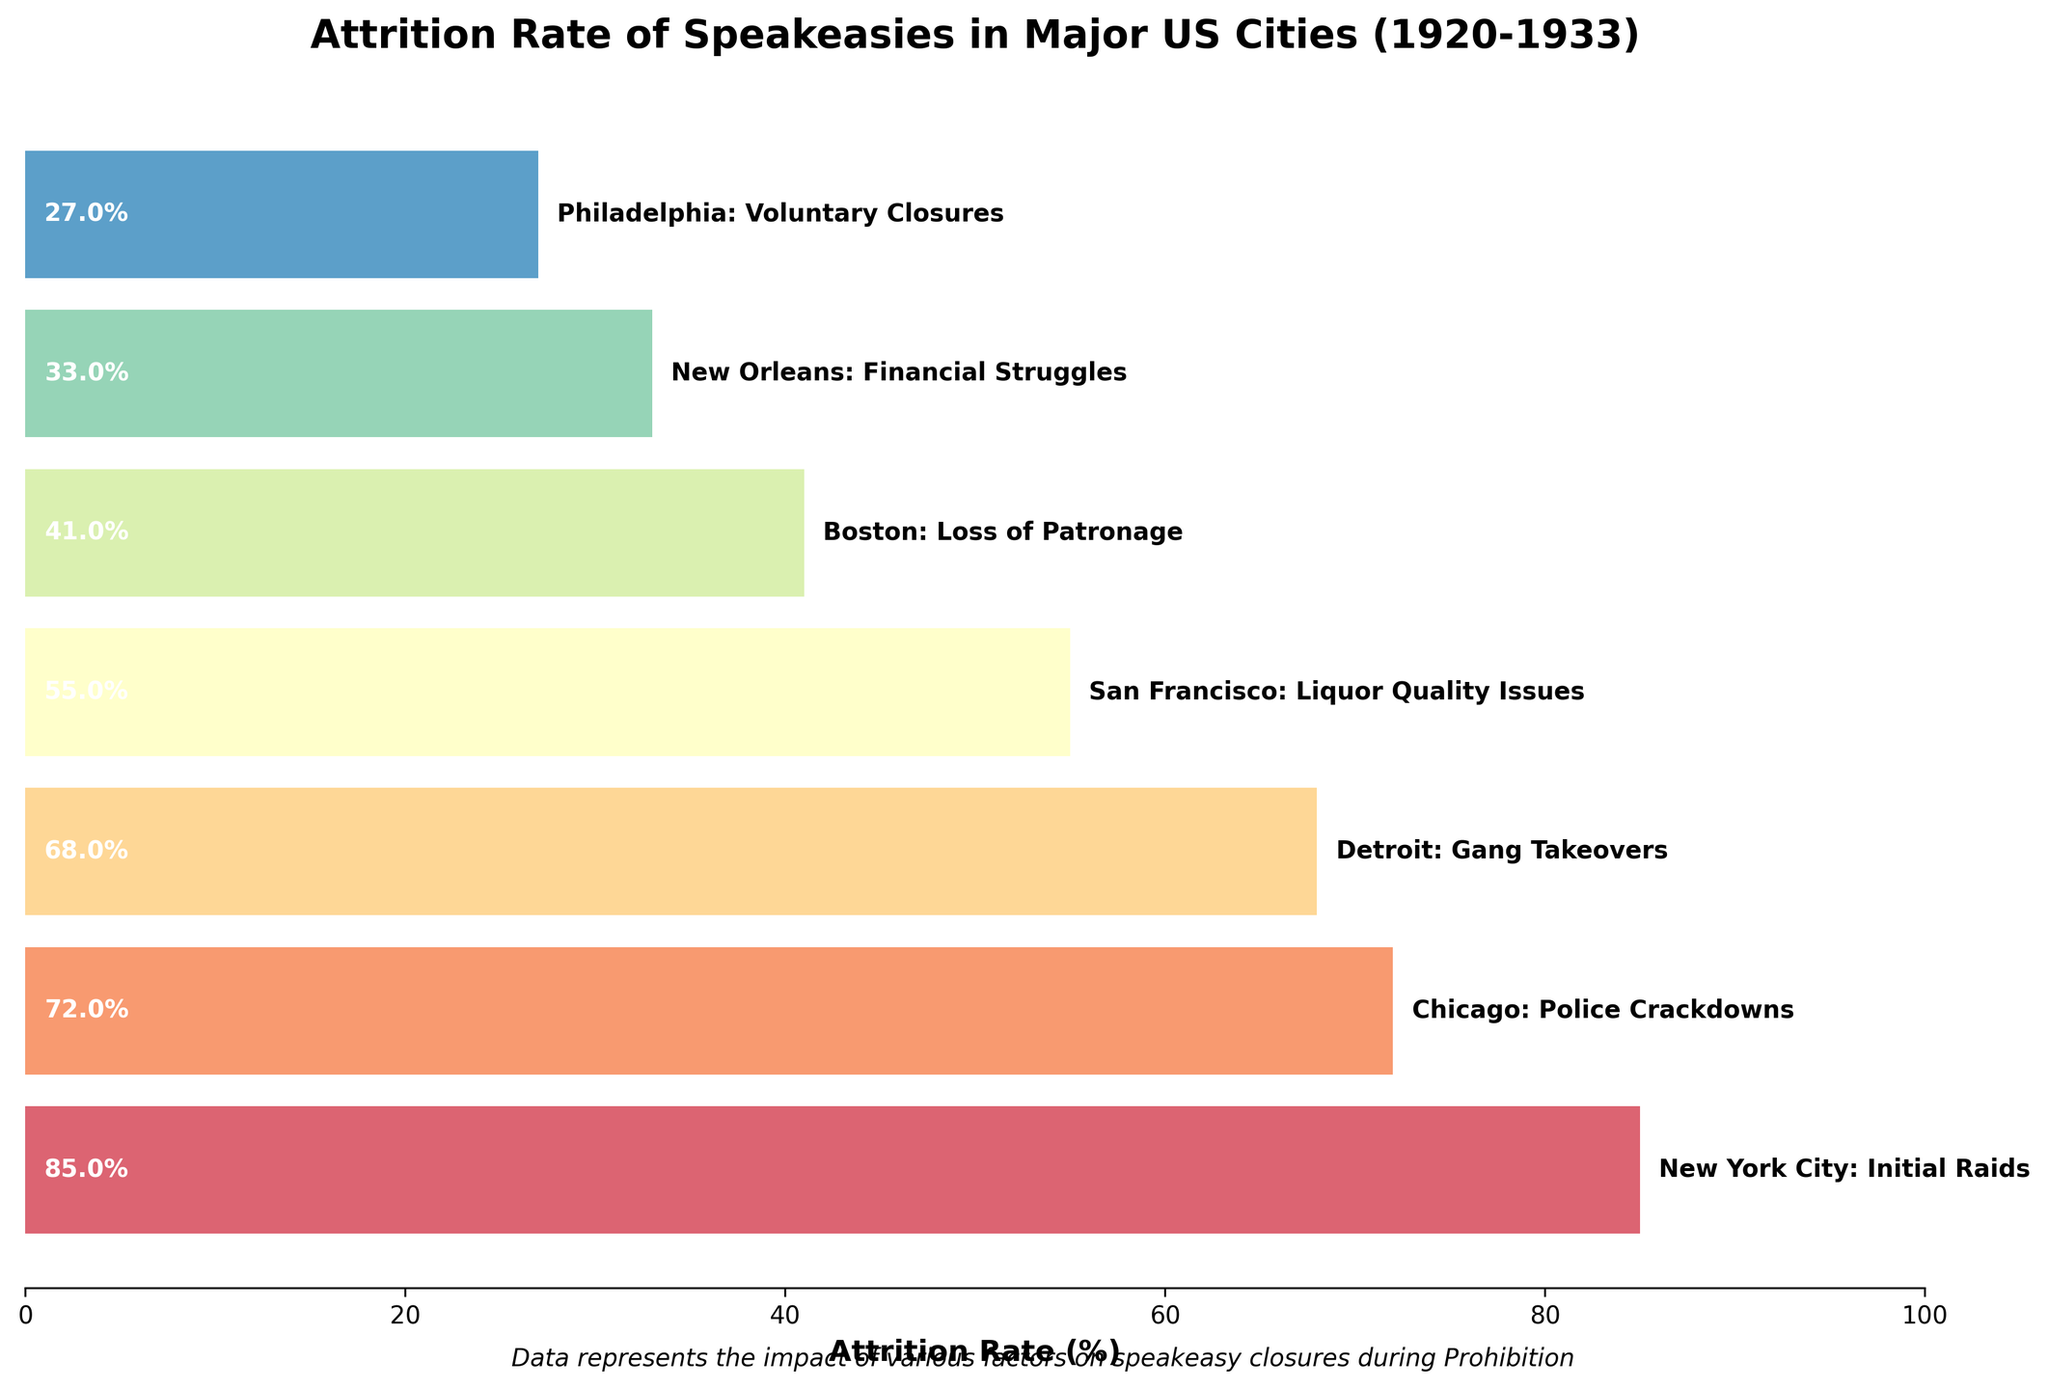What’s the title of the figure? The title is usually displayed prominently at the top of the figure. In this plot, it reads “Attrition Rate of Speakeasies in Major US Cities (1920-1933).”
Answer: Attrition Rate of Speakeasies in Major US Cities (1920-1933) Which city had the highest attrition rate? To determine the highest attrition rate, look for the longest bar in the horizontal bar chart. New York City has the longest bar with an attrition rate of 85%.
Answer: New York City What is the attrition rate for speakeasies in Boston? Locate the bar labeled "Boston" and observe the number adjacent to it that denotes the attrition rate. For Boston, the attrition rate is 41%.
Answer: 41% How does Philadelphia’s attrition rate compare to San Francisco’s? Identify the bars representing Philadelphia and San Francisco. Philadelphia’s attrition rate is 27%, while San Francisco’s is 55%. Comparing the two, Philadelphia’s rate is lower.
Answer: Philadelphia’s rate is lower Which issue corresponds with Detroit’s attrition rate? In the figure, each city has a description of the issue it's facing. The description next to the bar for Detroit reads "Gang Takeovers."
Answer: Gang Takeovers What’s the average attrition rate from all cities combined? To find the average: add all attrition rates (85 + 72 + 68 + 55 + 41 + 33 + 27) = 381, and divide by the number of cities (7). Therefore, the average attrition rate is 381/7 ≈ 54.43%.
Answer: 54.43% Which city had the lowest attrition rate and what was the cause? Look for the shortest bar in the chart, which represents the lowest attrition rate. This bar is for Philadelphia with an attrition rate of 27%. The cause is “Voluntary Closures.”
Answer: Philadelphia, Voluntary Closures How much greater is Chicago’s attrition rate compared to New Orleans? Subtract New Orleans’s attrition rate (33%) from Chicago’s (72%): 72 - 33 = 39%.
Answer: 39% What’s the sum of the attrition rates for Chicago and Boston? Add Chicago’s attrition rate (72%) with Boston’s (41%): 72 + 41 = 113%.
Answer: 113% Describe the gradient of colors used in the plot. The bars use colors that range from lighter to darker shades. This gradient is obtained by blending through a spectrum of colors, indicating variance in attrition rates among cities.
Answer: Lighter to darker gradient 